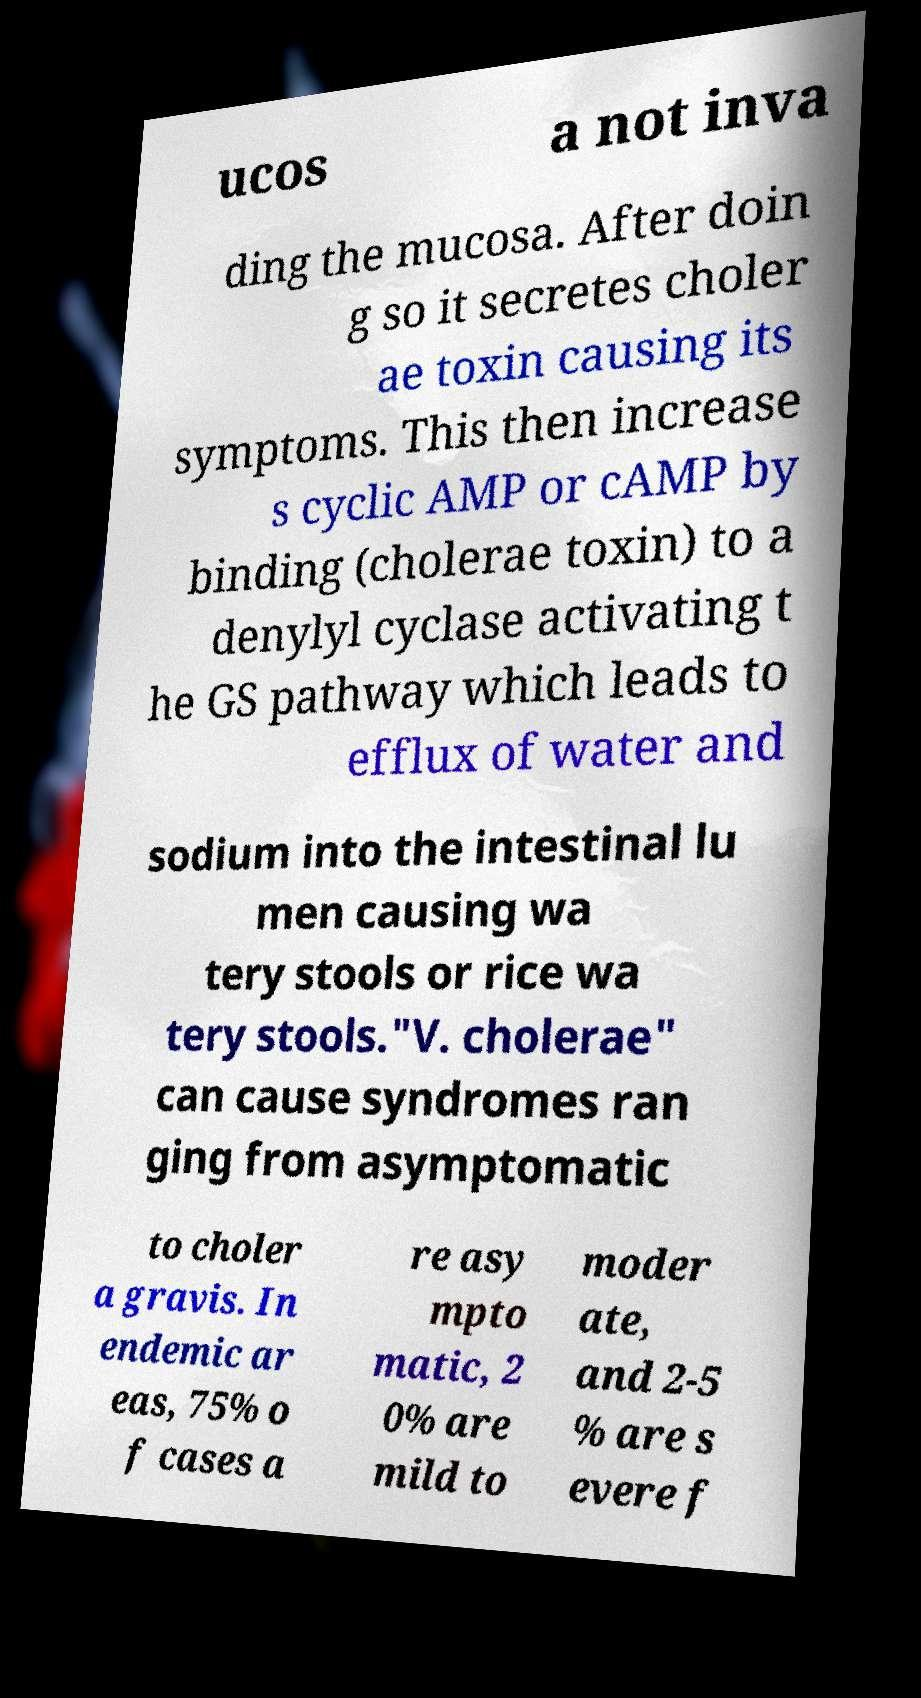Please identify and transcribe the text found in this image. ucos a not inva ding the mucosa. After doin g so it secretes choler ae toxin causing its symptoms. This then increase s cyclic AMP or cAMP by binding (cholerae toxin) to a denylyl cyclase activating t he GS pathway which leads to efflux of water and sodium into the intestinal lu men causing wa tery stools or rice wa tery stools."V. cholerae" can cause syndromes ran ging from asymptomatic to choler a gravis. In endemic ar eas, 75% o f cases a re asy mpto matic, 2 0% are mild to moder ate, and 2-5 % are s evere f 